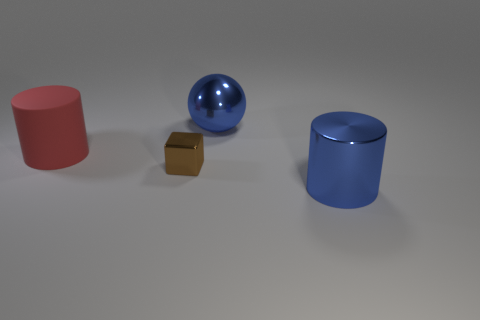The large blue object on the left side of the blue object in front of the tiny brown metallic block is what shape? The object you're referring to is a sphere. Specifically, it's a glossy blue sphere that is positioned on the left side of a cylindrical object with a similar color but a different shape. This sphere contrasts with the angular form of the tiny brown metallic block in front of it. 